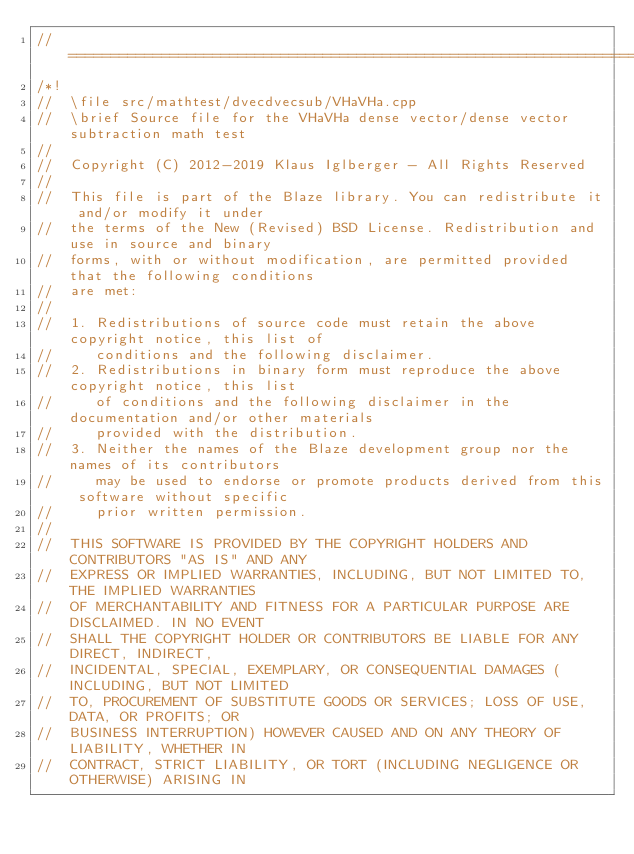Convert code to text. <code><loc_0><loc_0><loc_500><loc_500><_C++_>//=================================================================================================
/*!
//  \file src/mathtest/dvecdvecsub/VHaVHa.cpp
//  \brief Source file for the VHaVHa dense vector/dense vector subtraction math test
//
//  Copyright (C) 2012-2019 Klaus Iglberger - All Rights Reserved
//
//  This file is part of the Blaze library. You can redistribute it and/or modify it under
//  the terms of the New (Revised) BSD License. Redistribution and use in source and binary
//  forms, with or without modification, are permitted provided that the following conditions
//  are met:
//
//  1. Redistributions of source code must retain the above copyright notice, this list of
//     conditions and the following disclaimer.
//  2. Redistributions in binary form must reproduce the above copyright notice, this list
//     of conditions and the following disclaimer in the documentation and/or other materials
//     provided with the distribution.
//  3. Neither the names of the Blaze development group nor the names of its contributors
//     may be used to endorse or promote products derived from this software without specific
//     prior written permission.
//
//  THIS SOFTWARE IS PROVIDED BY THE COPYRIGHT HOLDERS AND CONTRIBUTORS "AS IS" AND ANY
//  EXPRESS OR IMPLIED WARRANTIES, INCLUDING, BUT NOT LIMITED TO, THE IMPLIED WARRANTIES
//  OF MERCHANTABILITY AND FITNESS FOR A PARTICULAR PURPOSE ARE DISCLAIMED. IN NO EVENT
//  SHALL THE COPYRIGHT HOLDER OR CONTRIBUTORS BE LIABLE FOR ANY DIRECT, INDIRECT,
//  INCIDENTAL, SPECIAL, EXEMPLARY, OR CONSEQUENTIAL DAMAGES (INCLUDING, BUT NOT LIMITED
//  TO, PROCUREMENT OF SUBSTITUTE GOODS OR SERVICES; LOSS OF USE, DATA, OR PROFITS; OR
//  BUSINESS INTERRUPTION) HOWEVER CAUSED AND ON ANY THEORY OF LIABILITY, WHETHER IN
//  CONTRACT, STRICT LIABILITY, OR TORT (INCLUDING NEGLIGENCE OR OTHERWISE) ARISING IN</code> 